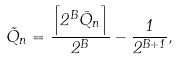<formula> <loc_0><loc_0><loc_500><loc_500>\tilde { Q } _ { n } = \frac { \left \lceil 2 ^ { B } \bar { Q } _ { n } \right \rceil } { 2 ^ { B } } - \frac { 1 } { 2 ^ { B + 1 } } ,</formula> 